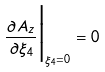<formula> <loc_0><loc_0><loc_500><loc_500>\frac { \partial A _ { z } } { \partial \xi _ { 4 } } \Big | _ { \xi _ { 4 } = 0 } = 0</formula> 